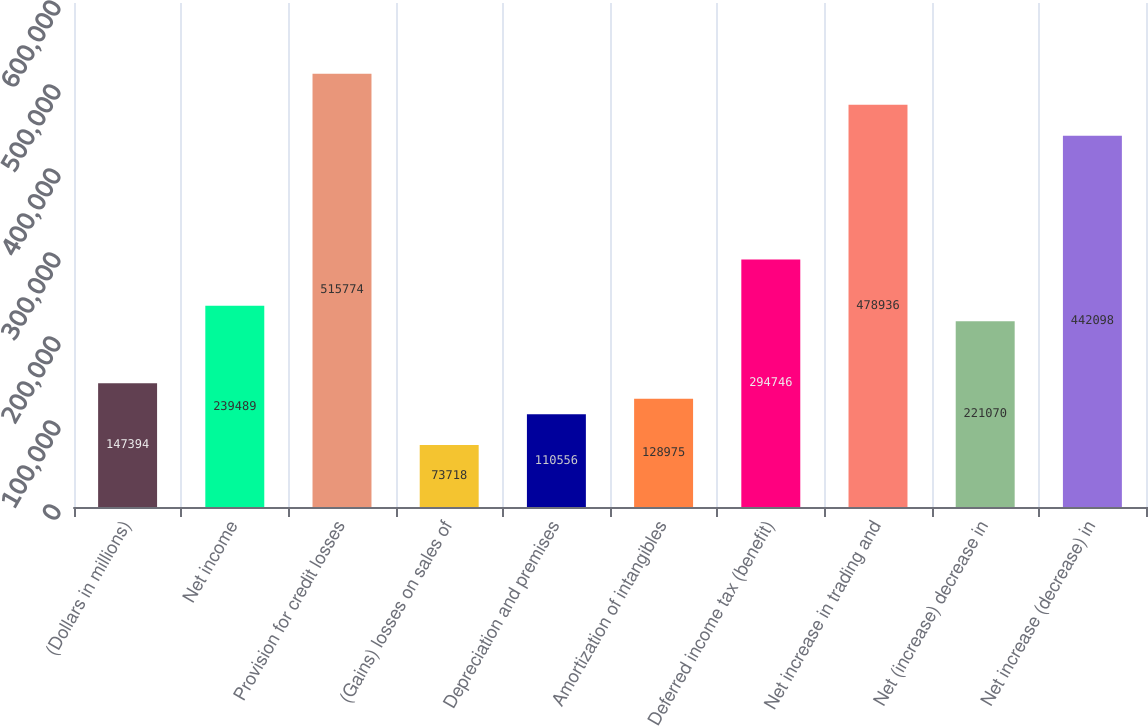Convert chart. <chart><loc_0><loc_0><loc_500><loc_500><bar_chart><fcel>(Dollars in millions)<fcel>Net income<fcel>Provision for credit losses<fcel>(Gains) losses on sales of<fcel>Depreciation and premises<fcel>Amortization of intangibles<fcel>Deferred income tax (benefit)<fcel>Net increase in trading and<fcel>Net (increase) decrease in<fcel>Net increase (decrease) in<nl><fcel>147394<fcel>239489<fcel>515774<fcel>73718<fcel>110556<fcel>128975<fcel>294746<fcel>478936<fcel>221070<fcel>442098<nl></chart> 